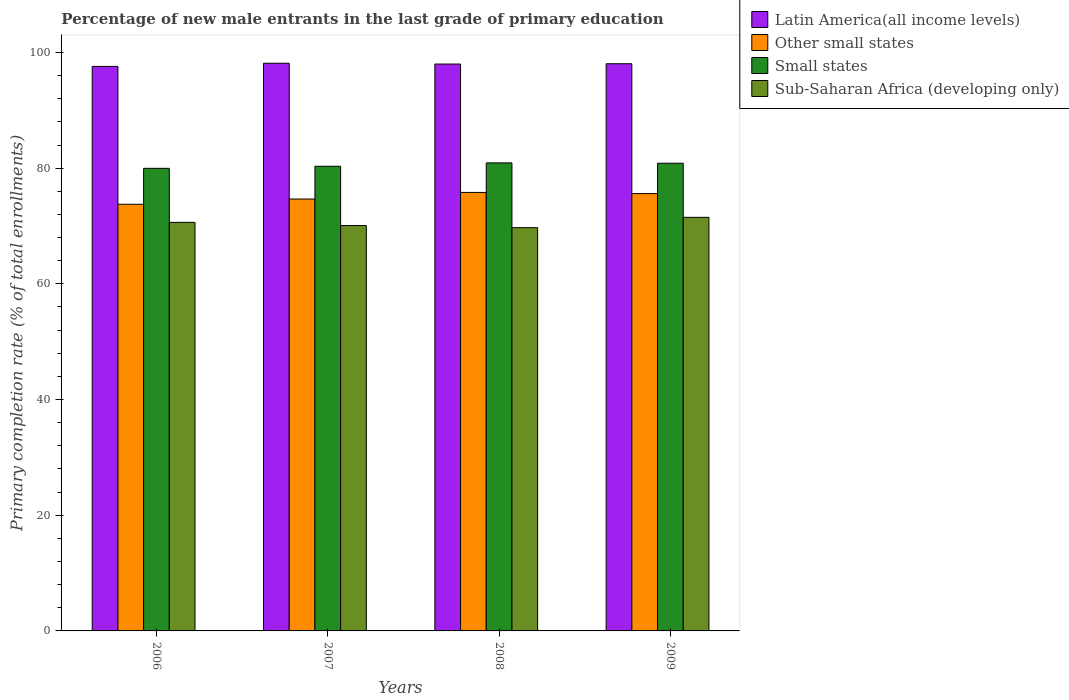How many different coloured bars are there?
Make the answer very short. 4. How many groups of bars are there?
Ensure brevity in your answer.  4. Are the number of bars on each tick of the X-axis equal?
Keep it short and to the point. Yes. In how many cases, is the number of bars for a given year not equal to the number of legend labels?
Give a very brief answer. 0. What is the percentage of new male entrants in Other small states in 2008?
Your response must be concise. 75.81. Across all years, what is the maximum percentage of new male entrants in Sub-Saharan Africa (developing only)?
Offer a terse response. 71.5. Across all years, what is the minimum percentage of new male entrants in Latin America(all income levels)?
Your answer should be compact. 97.59. What is the total percentage of new male entrants in Other small states in the graph?
Offer a terse response. 299.84. What is the difference between the percentage of new male entrants in Other small states in 2006 and that in 2008?
Give a very brief answer. -2.04. What is the difference between the percentage of new male entrants in Latin America(all income levels) in 2008 and the percentage of new male entrants in Sub-Saharan Africa (developing only) in 2009?
Give a very brief answer. 26.5. What is the average percentage of new male entrants in Other small states per year?
Make the answer very short. 74.96. In the year 2007, what is the difference between the percentage of new male entrants in Sub-Saharan Africa (developing only) and percentage of new male entrants in Other small states?
Make the answer very short. -4.59. In how many years, is the percentage of new male entrants in Small states greater than 92 %?
Give a very brief answer. 0. What is the ratio of the percentage of new male entrants in Latin America(all income levels) in 2008 to that in 2009?
Provide a succinct answer. 1. Is the percentage of new male entrants in Small states in 2006 less than that in 2007?
Offer a terse response. Yes. Is the difference between the percentage of new male entrants in Sub-Saharan Africa (developing only) in 2006 and 2007 greater than the difference between the percentage of new male entrants in Other small states in 2006 and 2007?
Offer a terse response. Yes. What is the difference between the highest and the second highest percentage of new male entrants in Latin America(all income levels)?
Provide a short and direct response. 0.08. What is the difference between the highest and the lowest percentage of new male entrants in Latin America(all income levels)?
Offer a very short reply. 0.54. Is the sum of the percentage of new male entrants in Other small states in 2008 and 2009 greater than the maximum percentage of new male entrants in Latin America(all income levels) across all years?
Offer a very short reply. Yes. What does the 2nd bar from the left in 2006 represents?
Offer a terse response. Other small states. What does the 4th bar from the right in 2006 represents?
Provide a short and direct response. Latin America(all income levels). Is it the case that in every year, the sum of the percentage of new male entrants in Sub-Saharan Africa (developing only) and percentage of new male entrants in Latin America(all income levels) is greater than the percentage of new male entrants in Other small states?
Your answer should be compact. Yes. How many bars are there?
Ensure brevity in your answer.  16. What is the difference between two consecutive major ticks on the Y-axis?
Give a very brief answer. 20. Are the values on the major ticks of Y-axis written in scientific E-notation?
Ensure brevity in your answer.  No. Does the graph contain any zero values?
Keep it short and to the point. No. Does the graph contain grids?
Make the answer very short. No. How many legend labels are there?
Offer a very short reply. 4. How are the legend labels stacked?
Provide a succinct answer. Vertical. What is the title of the graph?
Give a very brief answer. Percentage of new male entrants in the last grade of primary education. What is the label or title of the Y-axis?
Your answer should be very brief. Primary completion rate (% of total enrollments). What is the Primary completion rate (% of total enrollments) in Latin America(all income levels) in 2006?
Your answer should be compact. 97.59. What is the Primary completion rate (% of total enrollments) in Other small states in 2006?
Keep it short and to the point. 73.76. What is the Primary completion rate (% of total enrollments) of Small states in 2006?
Offer a very short reply. 79.97. What is the Primary completion rate (% of total enrollments) in Sub-Saharan Africa (developing only) in 2006?
Give a very brief answer. 70.63. What is the Primary completion rate (% of total enrollments) of Latin America(all income levels) in 2007?
Provide a short and direct response. 98.14. What is the Primary completion rate (% of total enrollments) of Other small states in 2007?
Offer a terse response. 74.67. What is the Primary completion rate (% of total enrollments) in Small states in 2007?
Ensure brevity in your answer.  80.33. What is the Primary completion rate (% of total enrollments) of Sub-Saharan Africa (developing only) in 2007?
Your response must be concise. 70.08. What is the Primary completion rate (% of total enrollments) in Latin America(all income levels) in 2008?
Offer a very short reply. 98. What is the Primary completion rate (% of total enrollments) of Other small states in 2008?
Provide a short and direct response. 75.81. What is the Primary completion rate (% of total enrollments) of Small states in 2008?
Provide a succinct answer. 80.91. What is the Primary completion rate (% of total enrollments) of Sub-Saharan Africa (developing only) in 2008?
Provide a succinct answer. 69.72. What is the Primary completion rate (% of total enrollments) in Latin America(all income levels) in 2009?
Your answer should be compact. 98.06. What is the Primary completion rate (% of total enrollments) of Other small states in 2009?
Give a very brief answer. 75.61. What is the Primary completion rate (% of total enrollments) in Small states in 2009?
Provide a short and direct response. 80.86. What is the Primary completion rate (% of total enrollments) in Sub-Saharan Africa (developing only) in 2009?
Ensure brevity in your answer.  71.5. Across all years, what is the maximum Primary completion rate (% of total enrollments) of Latin America(all income levels)?
Your answer should be very brief. 98.14. Across all years, what is the maximum Primary completion rate (% of total enrollments) in Other small states?
Ensure brevity in your answer.  75.81. Across all years, what is the maximum Primary completion rate (% of total enrollments) of Small states?
Keep it short and to the point. 80.91. Across all years, what is the maximum Primary completion rate (% of total enrollments) of Sub-Saharan Africa (developing only)?
Your answer should be compact. 71.5. Across all years, what is the minimum Primary completion rate (% of total enrollments) in Latin America(all income levels)?
Your answer should be compact. 97.59. Across all years, what is the minimum Primary completion rate (% of total enrollments) in Other small states?
Provide a succinct answer. 73.76. Across all years, what is the minimum Primary completion rate (% of total enrollments) of Small states?
Your answer should be compact. 79.97. Across all years, what is the minimum Primary completion rate (% of total enrollments) in Sub-Saharan Africa (developing only)?
Your answer should be very brief. 69.72. What is the total Primary completion rate (% of total enrollments) in Latin America(all income levels) in the graph?
Give a very brief answer. 391.79. What is the total Primary completion rate (% of total enrollments) in Other small states in the graph?
Your answer should be very brief. 299.84. What is the total Primary completion rate (% of total enrollments) in Small states in the graph?
Give a very brief answer. 322.07. What is the total Primary completion rate (% of total enrollments) in Sub-Saharan Africa (developing only) in the graph?
Offer a terse response. 281.93. What is the difference between the Primary completion rate (% of total enrollments) of Latin America(all income levels) in 2006 and that in 2007?
Your answer should be very brief. -0.54. What is the difference between the Primary completion rate (% of total enrollments) of Other small states in 2006 and that in 2007?
Ensure brevity in your answer.  -0.91. What is the difference between the Primary completion rate (% of total enrollments) of Small states in 2006 and that in 2007?
Make the answer very short. -0.36. What is the difference between the Primary completion rate (% of total enrollments) of Sub-Saharan Africa (developing only) in 2006 and that in 2007?
Ensure brevity in your answer.  0.55. What is the difference between the Primary completion rate (% of total enrollments) in Latin America(all income levels) in 2006 and that in 2008?
Ensure brevity in your answer.  -0.41. What is the difference between the Primary completion rate (% of total enrollments) in Other small states in 2006 and that in 2008?
Ensure brevity in your answer.  -2.04. What is the difference between the Primary completion rate (% of total enrollments) in Small states in 2006 and that in 2008?
Give a very brief answer. -0.94. What is the difference between the Primary completion rate (% of total enrollments) of Sub-Saharan Africa (developing only) in 2006 and that in 2008?
Your answer should be compact. 0.91. What is the difference between the Primary completion rate (% of total enrollments) of Latin America(all income levels) in 2006 and that in 2009?
Make the answer very short. -0.46. What is the difference between the Primary completion rate (% of total enrollments) of Other small states in 2006 and that in 2009?
Your answer should be compact. -1.84. What is the difference between the Primary completion rate (% of total enrollments) in Small states in 2006 and that in 2009?
Keep it short and to the point. -0.88. What is the difference between the Primary completion rate (% of total enrollments) in Sub-Saharan Africa (developing only) in 2006 and that in 2009?
Offer a very short reply. -0.87. What is the difference between the Primary completion rate (% of total enrollments) in Latin America(all income levels) in 2007 and that in 2008?
Your answer should be very brief. 0.14. What is the difference between the Primary completion rate (% of total enrollments) in Other small states in 2007 and that in 2008?
Provide a succinct answer. -1.14. What is the difference between the Primary completion rate (% of total enrollments) in Small states in 2007 and that in 2008?
Keep it short and to the point. -0.58. What is the difference between the Primary completion rate (% of total enrollments) of Sub-Saharan Africa (developing only) in 2007 and that in 2008?
Your answer should be compact. 0.36. What is the difference between the Primary completion rate (% of total enrollments) in Latin America(all income levels) in 2007 and that in 2009?
Your answer should be compact. 0.08. What is the difference between the Primary completion rate (% of total enrollments) of Other small states in 2007 and that in 2009?
Your answer should be very brief. -0.94. What is the difference between the Primary completion rate (% of total enrollments) of Small states in 2007 and that in 2009?
Give a very brief answer. -0.52. What is the difference between the Primary completion rate (% of total enrollments) of Sub-Saharan Africa (developing only) in 2007 and that in 2009?
Your response must be concise. -1.42. What is the difference between the Primary completion rate (% of total enrollments) of Latin America(all income levels) in 2008 and that in 2009?
Give a very brief answer. -0.05. What is the difference between the Primary completion rate (% of total enrollments) in Other small states in 2008 and that in 2009?
Give a very brief answer. 0.2. What is the difference between the Primary completion rate (% of total enrollments) of Small states in 2008 and that in 2009?
Provide a short and direct response. 0.06. What is the difference between the Primary completion rate (% of total enrollments) in Sub-Saharan Africa (developing only) in 2008 and that in 2009?
Provide a short and direct response. -1.79. What is the difference between the Primary completion rate (% of total enrollments) of Latin America(all income levels) in 2006 and the Primary completion rate (% of total enrollments) of Other small states in 2007?
Your response must be concise. 22.93. What is the difference between the Primary completion rate (% of total enrollments) of Latin America(all income levels) in 2006 and the Primary completion rate (% of total enrollments) of Small states in 2007?
Your answer should be very brief. 17.26. What is the difference between the Primary completion rate (% of total enrollments) of Latin America(all income levels) in 2006 and the Primary completion rate (% of total enrollments) of Sub-Saharan Africa (developing only) in 2007?
Offer a very short reply. 27.52. What is the difference between the Primary completion rate (% of total enrollments) of Other small states in 2006 and the Primary completion rate (% of total enrollments) of Small states in 2007?
Give a very brief answer. -6.57. What is the difference between the Primary completion rate (% of total enrollments) of Other small states in 2006 and the Primary completion rate (% of total enrollments) of Sub-Saharan Africa (developing only) in 2007?
Ensure brevity in your answer.  3.69. What is the difference between the Primary completion rate (% of total enrollments) in Small states in 2006 and the Primary completion rate (% of total enrollments) in Sub-Saharan Africa (developing only) in 2007?
Your answer should be compact. 9.89. What is the difference between the Primary completion rate (% of total enrollments) in Latin America(all income levels) in 2006 and the Primary completion rate (% of total enrollments) in Other small states in 2008?
Provide a short and direct response. 21.79. What is the difference between the Primary completion rate (% of total enrollments) in Latin America(all income levels) in 2006 and the Primary completion rate (% of total enrollments) in Small states in 2008?
Offer a very short reply. 16.68. What is the difference between the Primary completion rate (% of total enrollments) of Latin America(all income levels) in 2006 and the Primary completion rate (% of total enrollments) of Sub-Saharan Africa (developing only) in 2008?
Your answer should be very brief. 27.88. What is the difference between the Primary completion rate (% of total enrollments) in Other small states in 2006 and the Primary completion rate (% of total enrollments) in Small states in 2008?
Ensure brevity in your answer.  -7.15. What is the difference between the Primary completion rate (% of total enrollments) in Other small states in 2006 and the Primary completion rate (% of total enrollments) in Sub-Saharan Africa (developing only) in 2008?
Provide a succinct answer. 4.05. What is the difference between the Primary completion rate (% of total enrollments) in Small states in 2006 and the Primary completion rate (% of total enrollments) in Sub-Saharan Africa (developing only) in 2008?
Provide a succinct answer. 10.25. What is the difference between the Primary completion rate (% of total enrollments) in Latin America(all income levels) in 2006 and the Primary completion rate (% of total enrollments) in Other small states in 2009?
Provide a short and direct response. 21.99. What is the difference between the Primary completion rate (% of total enrollments) in Latin America(all income levels) in 2006 and the Primary completion rate (% of total enrollments) in Small states in 2009?
Make the answer very short. 16.74. What is the difference between the Primary completion rate (% of total enrollments) in Latin America(all income levels) in 2006 and the Primary completion rate (% of total enrollments) in Sub-Saharan Africa (developing only) in 2009?
Make the answer very short. 26.09. What is the difference between the Primary completion rate (% of total enrollments) of Other small states in 2006 and the Primary completion rate (% of total enrollments) of Small states in 2009?
Keep it short and to the point. -7.09. What is the difference between the Primary completion rate (% of total enrollments) of Other small states in 2006 and the Primary completion rate (% of total enrollments) of Sub-Saharan Africa (developing only) in 2009?
Provide a succinct answer. 2.26. What is the difference between the Primary completion rate (% of total enrollments) of Small states in 2006 and the Primary completion rate (% of total enrollments) of Sub-Saharan Africa (developing only) in 2009?
Your answer should be very brief. 8.47. What is the difference between the Primary completion rate (% of total enrollments) in Latin America(all income levels) in 2007 and the Primary completion rate (% of total enrollments) in Other small states in 2008?
Keep it short and to the point. 22.33. What is the difference between the Primary completion rate (% of total enrollments) of Latin America(all income levels) in 2007 and the Primary completion rate (% of total enrollments) of Small states in 2008?
Ensure brevity in your answer.  17.22. What is the difference between the Primary completion rate (% of total enrollments) in Latin America(all income levels) in 2007 and the Primary completion rate (% of total enrollments) in Sub-Saharan Africa (developing only) in 2008?
Keep it short and to the point. 28.42. What is the difference between the Primary completion rate (% of total enrollments) of Other small states in 2007 and the Primary completion rate (% of total enrollments) of Small states in 2008?
Provide a succinct answer. -6.25. What is the difference between the Primary completion rate (% of total enrollments) in Other small states in 2007 and the Primary completion rate (% of total enrollments) in Sub-Saharan Africa (developing only) in 2008?
Your answer should be very brief. 4.95. What is the difference between the Primary completion rate (% of total enrollments) of Small states in 2007 and the Primary completion rate (% of total enrollments) of Sub-Saharan Africa (developing only) in 2008?
Provide a short and direct response. 10.62. What is the difference between the Primary completion rate (% of total enrollments) of Latin America(all income levels) in 2007 and the Primary completion rate (% of total enrollments) of Other small states in 2009?
Make the answer very short. 22.53. What is the difference between the Primary completion rate (% of total enrollments) of Latin America(all income levels) in 2007 and the Primary completion rate (% of total enrollments) of Small states in 2009?
Your response must be concise. 17.28. What is the difference between the Primary completion rate (% of total enrollments) in Latin America(all income levels) in 2007 and the Primary completion rate (% of total enrollments) in Sub-Saharan Africa (developing only) in 2009?
Your answer should be very brief. 26.64. What is the difference between the Primary completion rate (% of total enrollments) of Other small states in 2007 and the Primary completion rate (% of total enrollments) of Small states in 2009?
Offer a terse response. -6.19. What is the difference between the Primary completion rate (% of total enrollments) in Other small states in 2007 and the Primary completion rate (% of total enrollments) in Sub-Saharan Africa (developing only) in 2009?
Give a very brief answer. 3.17. What is the difference between the Primary completion rate (% of total enrollments) in Small states in 2007 and the Primary completion rate (% of total enrollments) in Sub-Saharan Africa (developing only) in 2009?
Ensure brevity in your answer.  8.83. What is the difference between the Primary completion rate (% of total enrollments) of Latin America(all income levels) in 2008 and the Primary completion rate (% of total enrollments) of Other small states in 2009?
Provide a short and direct response. 22.4. What is the difference between the Primary completion rate (% of total enrollments) in Latin America(all income levels) in 2008 and the Primary completion rate (% of total enrollments) in Small states in 2009?
Your answer should be compact. 17.15. What is the difference between the Primary completion rate (% of total enrollments) in Latin America(all income levels) in 2008 and the Primary completion rate (% of total enrollments) in Sub-Saharan Africa (developing only) in 2009?
Offer a very short reply. 26.5. What is the difference between the Primary completion rate (% of total enrollments) in Other small states in 2008 and the Primary completion rate (% of total enrollments) in Small states in 2009?
Make the answer very short. -5.05. What is the difference between the Primary completion rate (% of total enrollments) in Other small states in 2008 and the Primary completion rate (% of total enrollments) in Sub-Saharan Africa (developing only) in 2009?
Make the answer very short. 4.3. What is the difference between the Primary completion rate (% of total enrollments) in Small states in 2008 and the Primary completion rate (% of total enrollments) in Sub-Saharan Africa (developing only) in 2009?
Your answer should be compact. 9.41. What is the average Primary completion rate (% of total enrollments) in Latin America(all income levels) per year?
Your answer should be very brief. 97.95. What is the average Primary completion rate (% of total enrollments) in Other small states per year?
Ensure brevity in your answer.  74.96. What is the average Primary completion rate (% of total enrollments) in Small states per year?
Make the answer very short. 80.52. What is the average Primary completion rate (% of total enrollments) in Sub-Saharan Africa (developing only) per year?
Your answer should be very brief. 70.48. In the year 2006, what is the difference between the Primary completion rate (% of total enrollments) of Latin America(all income levels) and Primary completion rate (% of total enrollments) of Other small states?
Make the answer very short. 23.83. In the year 2006, what is the difference between the Primary completion rate (% of total enrollments) in Latin America(all income levels) and Primary completion rate (% of total enrollments) in Small states?
Your answer should be compact. 17.62. In the year 2006, what is the difference between the Primary completion rate (% of total enrollments) of Latin America(all income levels) and Primary completion rate (% of total enrollments) of Sub-Saharan Africa (developing only)?
Provide a succinct answer. 26.96. In the year 2006, what is the difference between the Primary completion rate (% of total enrollments) in Other small states and Primary completion rate (% of total enrollments) in Small states?
Offer a terse response. -6.21. In the year 2006, what is the difference between the Primary completion rate (% of total enrollments) of Other small states and Primary completion rate (% of total enrollments) of Sub-Saharan Africa (developing only)?
Ensure brevity in your answer.  3.13. In the year 2006, what is the difference between the Primary completion rate (% of total enrollments) of Small states and Primary completion rate (% of total enrollments) of Sub-Saharan Africa (developing only)?
Your response must be concise. 9.34. In the year 2007, what is the difference between the Primary completion rate (% of total enrollments) of Latin America(all income levels) and Primary completion rate (% of total enrollments) of Other small states?
Give a very brief answer. 23.47. In the year 2007, what is the difference between the Primary completion rate (% of total enrollments) in Latin America(all income levels) and Primary completion rate (% of total enrollments) in Small states?
Make the answer very short. 17.81. In the year 2007, what is the difference between the Primary completion rate (% of total enrollments) in Latin America(all income levels) and Primary completion rate (% of total enrollments) in Sub-Saharan Africa (developing only)?
Offer a very short reply. 28.06. In the year 2007, what is the difference between the Primary completion rate (% of total enrollments) of Other small states and Primary completion rate (% of total enrollments) of Small states?
Give a very brief answer. -5.66. In the year 2007, what is the difference between the Primary completion rate (% of total enrollments) of Other small states and Primary completion rate (% of total enrollments) of Sub-Saharan Africa (developing only)?
Provide a short and direct response. 4.59. In the year 2007, what is the difference between the Primary completion rate (% of total enrollments) of Small states and Primary completion rate (% of total enrollments) of Sub-Saharan Africa (developing only)?
Your response must be concise. 10.25. In the year 2008, what is the difference between the Primary completion rate (% of total enrollments) of Latin America(all income levels) and Primary completion rate (% of total enrollments) of Other small states?
Ensure brevity in your answer.  22.2. In the year 2008, what is the difference between the Primary completion rate (% of total enrollments) in Latin America(all income levels) and Primary completion rate (% of total enrollments) in Small states?
Your response must be concise. 17.09. In the year 2008, what is the difference between the Primary completion rate (% of total enrollments) in Latin America(all income levels) and Primary completion rate (% of total enrollments) in Sub-Saharan Africa (developing only)?
Keep it short and to the point. 28.29. In the year 2008, what is the difference between the Primary completion rate (% of total enrollments) in Other small states and Primary completion rate (% of total enrollments) in Small states?
Your answer should be very brief. -5.11. In the year 2008, what is the difference between the Primary completion rate (% of total enrollments) in Other small states and Primary completion rate (% of total enrollments) in Sub-Saharan Africa (developing only)?
Provide a succinct answer. 6.09. In the year 2008, what is the difference between the Primary completion rate (% of total enrollments) in Small states and Primary completion rate (% of total enrollments) in Sub-Saharan Africa (developing only)?
Provide a succinct answer. 11.2. In the year 2009, what is the difference between the Primary completion rate (% of total enrollments) of Latin America(all income levels) and Primary completion rate (% of total enrollments) of Other small states?
Offer a terse response. 22.45. In the year 2009, what is the difference between the Primary completion rate (% of total enrollments) in Latin America(all income levels) and Primary completion rate (% of total enrollments) in Small states?
Your answer should be very brief. 17.2. In the year 2009, what is the difference between the Primary completion rate (% of total enrollments) of Latin America(all income levels) and Primary completion rate (% of total enrollments) of Sub-Saharan Africa (developing only)?
Make the answer very short. 26.55. In the year 2009, what is the difference between the Primary completion rate (% of total enrollments) in Other small states and Primary completion rate (% of total enrollments) in Small states?
Your answer should be very brief. -5.25. In the year 2009, what is the difference between the Primary completion rate (% of total enrollments) of Other small states and Primary completion rate (% of total enrollments) of Sub-Saharan Africa (developing only)?
Your response must be concise. 4.11. In the year 2009, what is the difference between the Primary completion rate (% of total enrollments) of Small states and Primary completion rate (% of total enrollments) of Sub-Saharan Africa (developing only)?
Give a very brief answer. 9.35. What is the ratio of the Primary completion rate (% of total enrollments) in Latin America(all income levels) in 2006 to that in 2007?
Keep it short and to the point. 0.99. What is the ratio of the Primary completion rate (% of total enrollments) in Other small states in 2006 to that in 2007?
Offer a very short reply. 0.99. What is the ratio of the Primary completion rate (% of total enrollments) of Small states in 2006 to that in 2007?
Your response must be concise. 1. What is the ratio of the Primary completion rate (% of total enrollments) in Sub-Saharan Africa (developing only) in 2006 to that in 2007?
Provide a short and direct response. 1.01. What is the ratio of the Primary completion rate (% of total enrollments) of Latin America(all income levels) in 2006 to that in 2008?
Your response must be concise. 1. What is the ratio of the Primary completion rate (% of total enrollments) of Other small states in 2006 to that in 2008?
Keep it short and to the point. 0.97. What is the ratio of the Primary completion rate (% of total enrollments) in Small states in 2006 to that in 2008?
Ensure brevity in your answer.  0.99. What is the ratio of the Primary completion rate (% of total enrollments) of Sub-Saharan Africa (developing only) in 2006 to that in 2008?
Offer a terse response. 1.01. What is the ratio of the Primary completion rate (% of total enrollments) in Latin America(all income levels) in 2006 to that in 2009?
Your response must be concise. 1. What is the ratio of the Primary completion rate (% of total enrollments) of Other small states in 2006 to that in 2009?
Give a very brief answer. 0.98. What is the ratio of the Primary completion rate (% of total enrollments) in Small states in 2006 to that in 2009?
Offer a very short reply. 0.99. What is the ratio of the Primary completion rate (% of total enrollments) in Latin America(all income levels) in 2007 to that in 2008?
Offer a terse response. 1. What is the ratio of the Primary completion rate (% of total enrollments) in Sub-Saharan Africa (developing only) in 2007 to that in 2008?
Provide a short and direct response. 1.01. What is the ratio of the Primary completion rate (% of total enrollments) of Other small states in 2007 to that in 2009?
Your answer should be very brief. 0.99. What is the ratio of the Primary completion rate (% of total enrollments) of Small states in 2007 to that in 2009?
Provide a short and direct response. 0.99. What is the ratio of the Primary completion rate (% of total enrollments) in Sub-Saharan Africa (developing only) in 2007 to that in 2009?
Give a very brief answer. 0.98. What is the ratio of the Primary completion rate (% of total enrollments) of Latin America(all income levels) in 2008 to that in 2009?
Make the answer very short. 1. What is the ratio of the Primary completion rate (% of total enrollments) in Other small states in 2008 to that in 2009?
Your response must be concise. 1. What is the difference between the highest and the second highest Primary completion rate (% of total enrollments) of Latin America(all income levels)?
Your response must be concise. 0.08. What is the difference between the highest and the second highest Primary completion rate (% of total enrollments) in Other small states?
Keep it short and to the point. 0.2. What is the difference between the highest and the second highest Primary completion rate (% of total enrollments) in Small states?
Keep it short and to the point. 0.06. What is the difference between the highest and the second highest Primary completion rate (% of total enrollments) of Sub-Saharan Africa (developing only)?
Keep it short and to the point. 0.87. What is the difference between the highest and the lowest Primary completion rate (% of total enrollments) of Latin America(all income levels)?
Make the answer very short. 0.54. What is the difference between the highest and the lowest Primary completion rate (% of total enrollments) of Other small states?
Offer a terse response. 2.04. What is the difference between the highest and the lowest Primary completion rate (% of total enrollments) of Small states?
Ensure brevity in your answer.  0.94. What is the difference between the highest and the lowest Primary completion rate (% of total enrollments) in Sub-Saharan Africa (developing only)?
Make the answer very short. 1.79. 